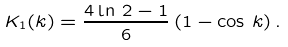<formula> <loc_0><loc_0><loc_500><loc_500>K _ { 1 } ( k ) = \frac { 4 \ln \, 2 - 1 } 6 \, ( 1 - \cos \, k ) \, .</formula> 